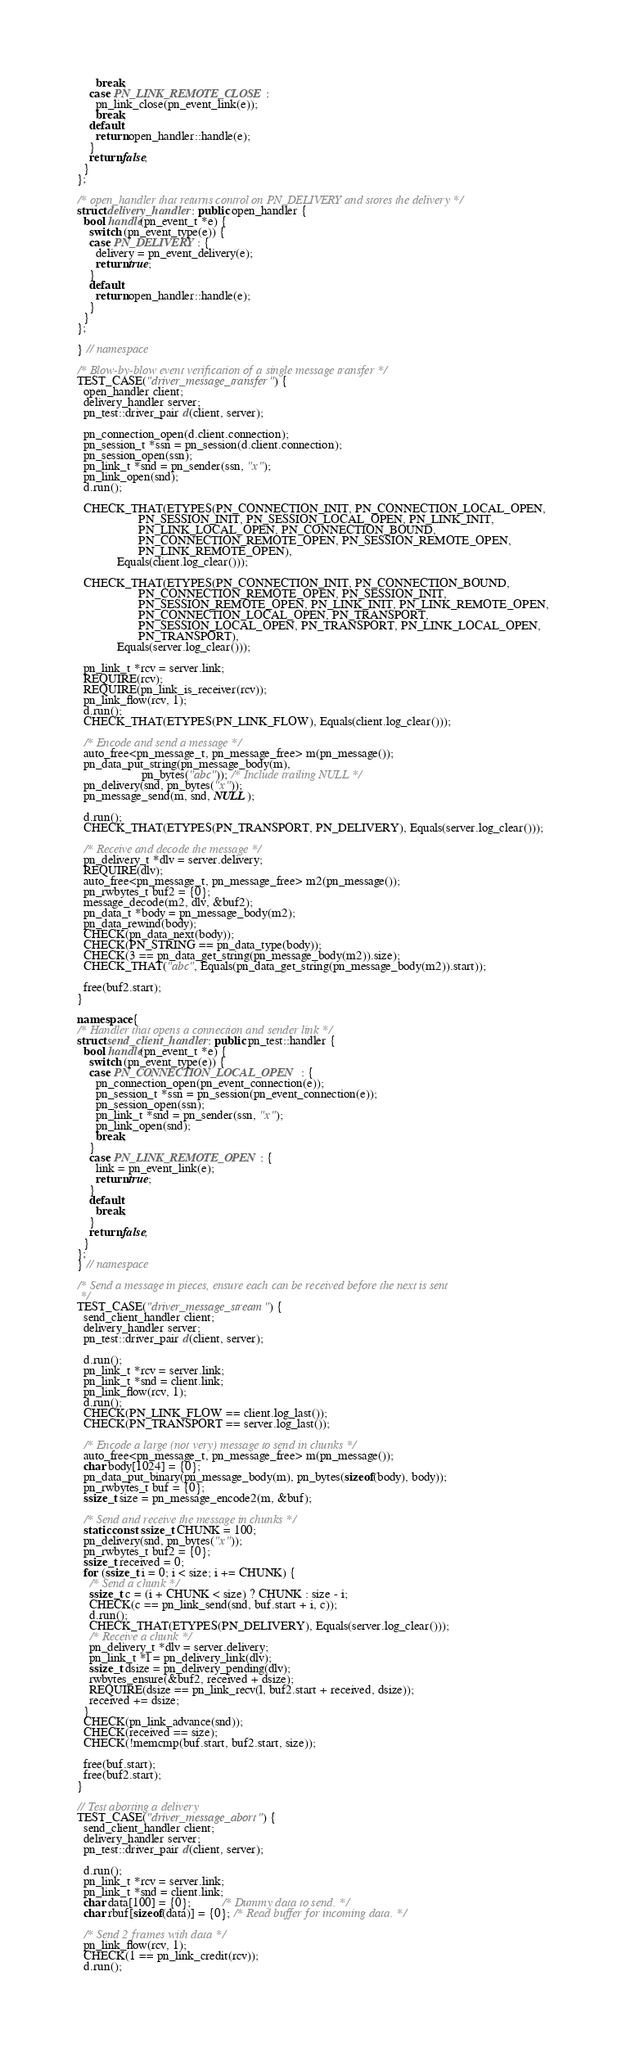<code> <loc_0><loc_0><loc_500><loc_500><_C++_>      break;
    case PN_LINK_REMOTE_CLOSE:
      pn_link_close(pn_event_link(e));
      break;
    default:
      return open_handler::handle(e);
    }
    return false;
  }
};

/* open_handler that returns control on PN_DELIVERY and stores the delivery */
struct delivery_handler : public open_handler {
  bool handle(pn_event_t *e) {
    switch (pn_event_type(e)) {
    case PN_DELIVERY: {
      delivery = pn_event_delivery(e);
      return true;
    }
    default:
      return open_handler::handle(e);
    }
  }
};

} // namespace

/* Blow-by-blow event verification of a single message transfer */
TEST_CASE("driver_message_transfer") {
  open_handler client;
  delivery_handler server;
  pn_test::driver_pair d(client, server);

  pn_connection_open(d.client.connection);
  pn_session_t *ssn = pn_session(d.client.connection);
  pn_session_open(ssn);
  pn_link_t *snd = pn_sender(ssn, "x");
  pn_link_open(snd);
  d.run();

  CHECK_THAT(ETYPES(PN_CONNECTION_INIT, PN_CONNECTION_LOCAL_OPEN,
                    PN_SESSION_INIT, PN_SESSION_LOCAL_OPEN, PN_LINK_INIT,
                    PN_LINK_LOCAL_OPEN, PN_CONNECTION_BOUND,
                    PN_CONNECTION_REMOTE_OPEN, PN_SESSION_REMOTE_OPEN,
                    PN_LINK_REMOTE_OPEN),
             Equals(client.log_clear()));

  CHECK_THAT(ETYPES(PN_CONNECTION_INIT, PN_CONNECTION_BOUND,
                    PN_CONNECTION_REMOTE_OPEN, PN_SESSION_INIT,
                    PN_SESSION_REMOTE_OPEN, PN_LINK_INIT, PN_LINK_REMOTE_OPEN,
                    PN_CONNECTION_LOCAL_OPEN, PN_TRANSPORT,
                    PN_SESSION_LOCAL_OPEN, PN_TRANSPORT, PN_LINK_LOCAL_OPEN,
                    PN_TRANSPORT),
             Equals(server.log_clear()));

  pn_link_t *rcv = server.link;
  REQUIRE(rcv);
  REQUIRE(pn_link_is_receiver(rcv));
  pn_link_flow(rcv, 1);
  d.run();
  CHECK_THAT(ETYPES(PN_LINK_FLOW), Equals(client.log_clear()));

  /* Encode and send a message */
  auto_free<pn_message_t, pn_message_free> m(pn_message());
  pn_data_put_string(pn_message_body(m),
                     pn_bytes("abc")); /* Include trailing NULL */
  pn_delivery(snd, pn_bytes("x"));
  pn_message_send(m, snd, NULL);

  d.run();
  CHECK_THAT(ETYPES(PN_TRANSPORT, PN_DELIVERY), Equals(server.log_clear()));

  /* Receive and decode the message */
  pn_delivery_t *dlv = server.delivery;
  REQUIRE(dlv);
  auto_free<pn_message_t, pn_message_free> m2(pn_message());
  pn_rwbytes_t buf2 = {0};
  message_decode(m2, dlv, &buf2);
  pn_data_t *body = pn_message_body(m2);
  pn_data_rewind(body);
  CHECK(pn_data_next(body));
  CHECK(PN_STRING == pn_data_type(body));
  CHECK(3 == pn_data_get_string(pn_message_body(m2)).size);
  CHECK_THAT("abc", Equals(pn_data_get_string(pn_message_body(m2)).start));

  free(buf2.start);
}

namespace {
/* Handler that opens a connection and sender link */
struct send_client_handler : public pn_test::handler {
  bool handle(pn_event_t *e) {
    switch (pn_event_type(e)) {
    case PN_CONNECTION_LOCAL_OPEN: {
      pn_connection_open(pn_event_connection(e));
      pn_session_t *ssn = pn_session(pn_event_connection(e));
      pn_session_open(ssn);
      pn_link_t *snd = pn_sender(ssn, "x");
      pn_link_open(snd);
      break;
    }
    case PN_LINK_REMOTE_OPEN: {
      link = pn_event_link(e);
      return true;
    }
    default:
      break;
    }
    return false;
  }
};
} // namespace

/* Send a message in pieces, ensure each can be received before the next is sent
 */
TEST_CASE("driver_message_stream") {
  send_client_handler client;
  delivery_handler server;
  pn_test::driver_pair d(client, server);

  d.run();
  pn_link_t *rcv = server.link;
  pn_link_t *snd = client.link;
  pn_link_flow(rcv, 1);
  d.run();
  CHECK(PN_LINK_FLOW == client.log_last());
  CHECK(PN_TRANSPORT == server.log_last());

  /* Encode a large (not very) message to send in chunks */
  auto_free<pn_message_t, pn_message_free> m(pn_message());
  char body[1024] = {0};
  pn_data_put_binary(pn_message_body(m), pn_bytes(sizeof(body), body));
  pn_rwbytes_t buf = {0};
  ssize_t size = pn_message_encode2(m, &buf);

  /* Send and receive the message in chunks */
  static const ssize_t CHUNK = 100;
  pn_delivery(snd, pn_bytes("x"));
  pn_rwbytes_t buf2 = {0};
  ssize_t received = 0;
  for (ssize_t i = 0; i < size; i += CHUNK) {
    /* Send a chunk */
    ssize_t c = (i + CHUNK < size) ? CHUNK : size - i;
    CHECK(c == pn_link_send(snd, buf.start + i, c));
    d.run();
    CHECK_THAT(ETYPES(PN_DELIVERY), Equals(server.log_clear()));
    /* Receive a chunk */
    pn_delivery_t *dlv = server.delivery;
    pn_link_t *l = pn_delivery_link(dlv);
    ssize_t dsize = pn_delivery_pending(dlv);
    rwbytes_ensure(&buf2, received + dsize);
    REQUIRE(dsize == pn_link_recv(l, buf2.start + received, dsize));
    received += dsize;
  }
  CHECK(pn_link_advance(snd));
  CHECK(received == size);
  CHECK(!memcmp(buf.start, buf2.start, size));

  free(buf.start);
  free(buf2.start);
}

// Test aborting a delivery
TEST_CASE("driver_message_abort") {
  send_client_handler client;
  delivery_handler server;
  pn_test::driver_pair d(client, server);

  d.run();
  pn_link_t *rcv = server.link;
  pn_link_t *snd = client.link;
  char data[100] = {0};          /* Dummy data to send. */
  char rbuf[sizeof(data)] = {0}; /* Read buffer for incoming data. */

  /* Send 2 frames with data */
  pn_link_flow(rcv, 1);
  CHECK(1 == pn_link_credit(rcv));
  d.run();</code> 